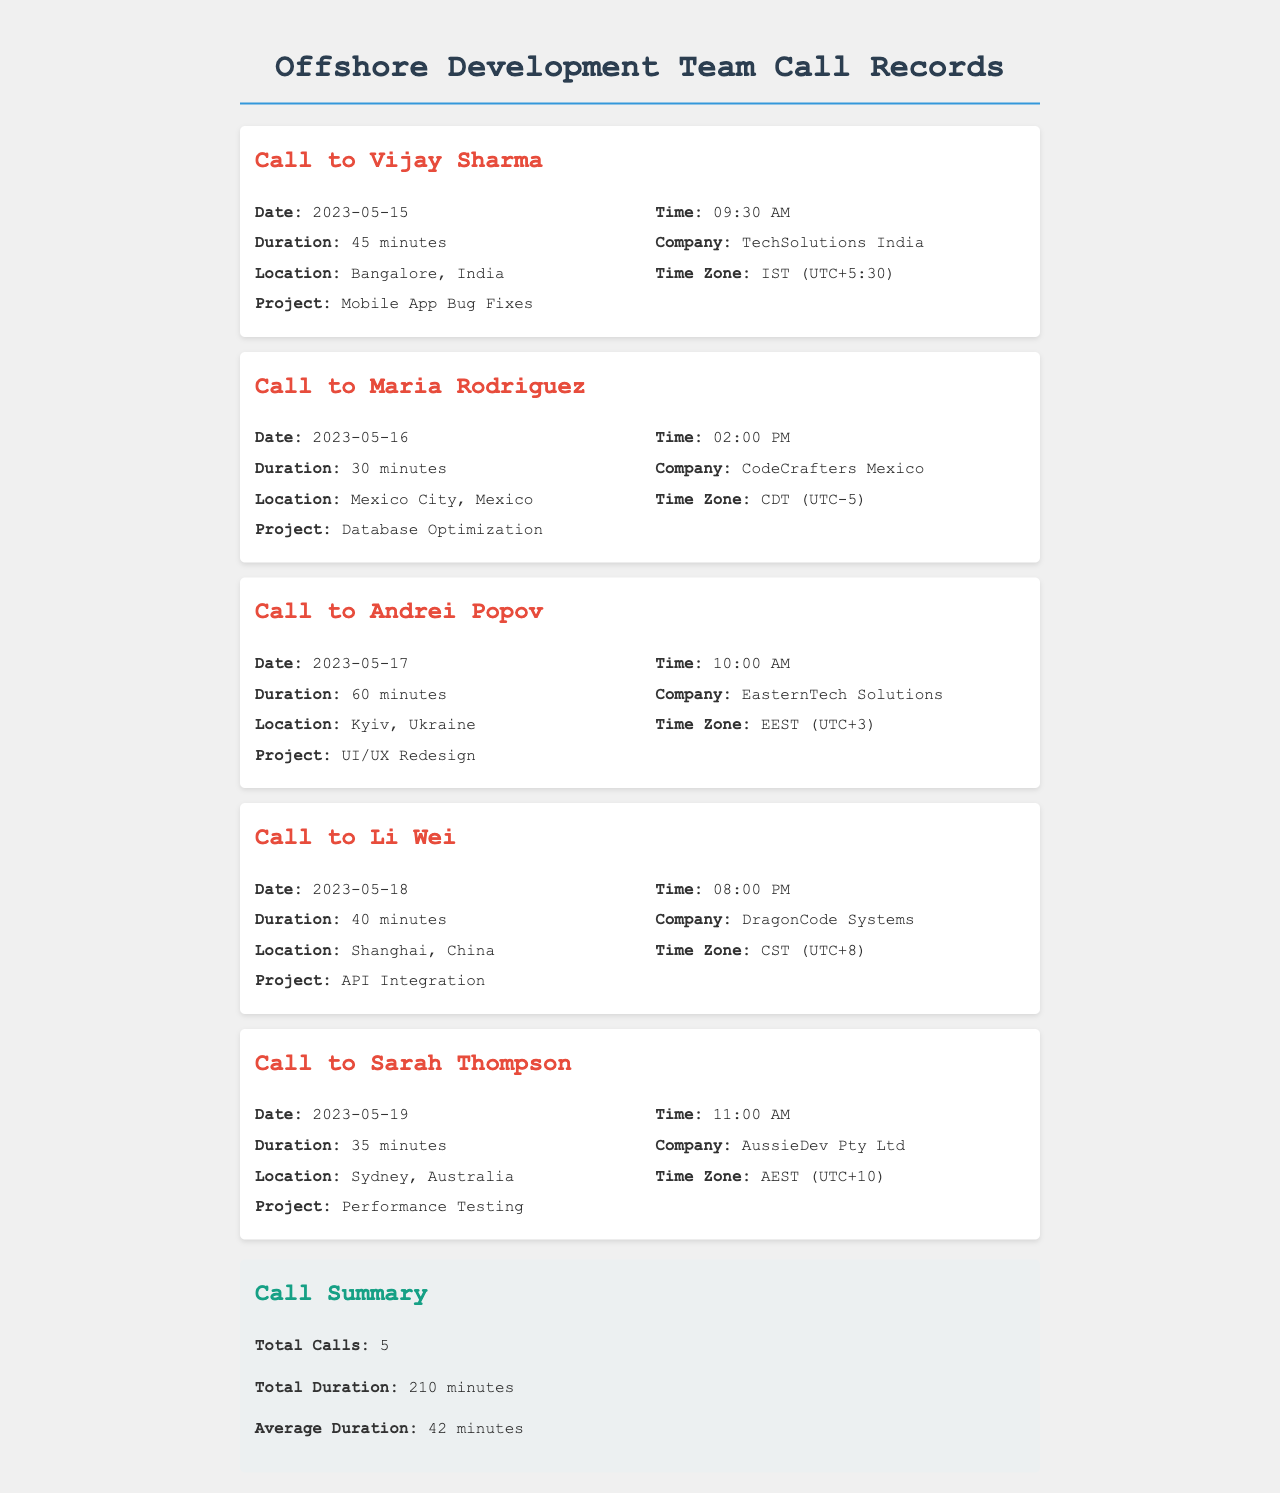What is the date of the call to Vijay Sharma? The date of the call is mentioned in the call record for Vijay Sharma, which is 2023-05-15.
Answer: 2023-05-15 What is the duration of the call to Maria Rodriguez? The duration is specified in the call record for Maria Rodriguez, which is 30 minutes.
Answer: 30 minutes Which company is associated with the call to Andrei Popov? The company is listed in the call record for Andrei Popov, which is EasternTech Solutions.
Answer: EasternTech Solutions What is the time zone for the call to Li Wei? The time zone is provided in the call record for Li Wei, which is CST (UTC+8).
Answer: CST (UTC+8) Who was the call to on 2023-05-19? The call date is noted in the call record, indicating that it was to Sarah Thompson.
Answer: Sarah Thompson What is the total duration of all calls? The total duration is calculated and presented in the summary section of the document, which is 210 minutes.
Answer: 210 minutes What project was discussed during the call to Sarah Thompson? The project is mentioned in the call record for Sarah Thompson, which is Performance Testing.
Answer: Performance Testing How many minutes was the call to Vijay Sharma? The duration is specified in the call record for Vijay Sharma, which is 45 minutes.
Answer: 45 minutes What is the average duration of the calls made? The average duration is detailed in the summary section of the document, which is 42 minutes.
Answer: 42 minutes 